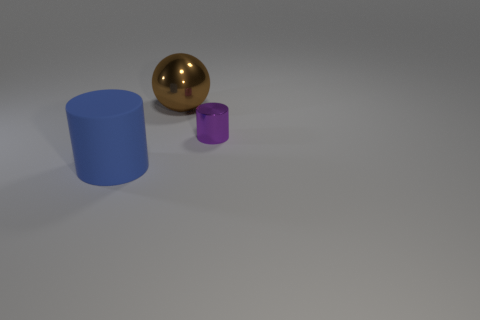How many other objects are the same material as the tiny purple cylinder?
Your response must be concise. 1. Is there a tiny purple object behind the object to the right of the large thing behind the big rubber thing?
Provide a short and direct response. No. Do the small purple thing and the blue cylinder have the same material?
Your answer should be very brief. No. Is there any other thing that has the same shape as the brown thing?
Keep it short and to the point. No. There is a large object behind the big object that is in front of the purple metallic cylinder; what is it made of?
Provide a short and direct response. Metal. There is a cylinder that is behind the large cylinder; how big is it?
Provide a succinct answer. Small. There is a thing that is both in front of the big brown object and right of the blue cylinder; what is its color?
Your response must be concise. Purple. Do the cylinder that is on the right side of the matte cylinder and the matte cylinder have the same size?
Offer a very short reply. No. There is a cylinder that is to the left of the brown metal ball; is there a purple object in front of it?
Keep it short and to the point. No. What material is the purple cylinder?
Give a very brief answer. Metal. 